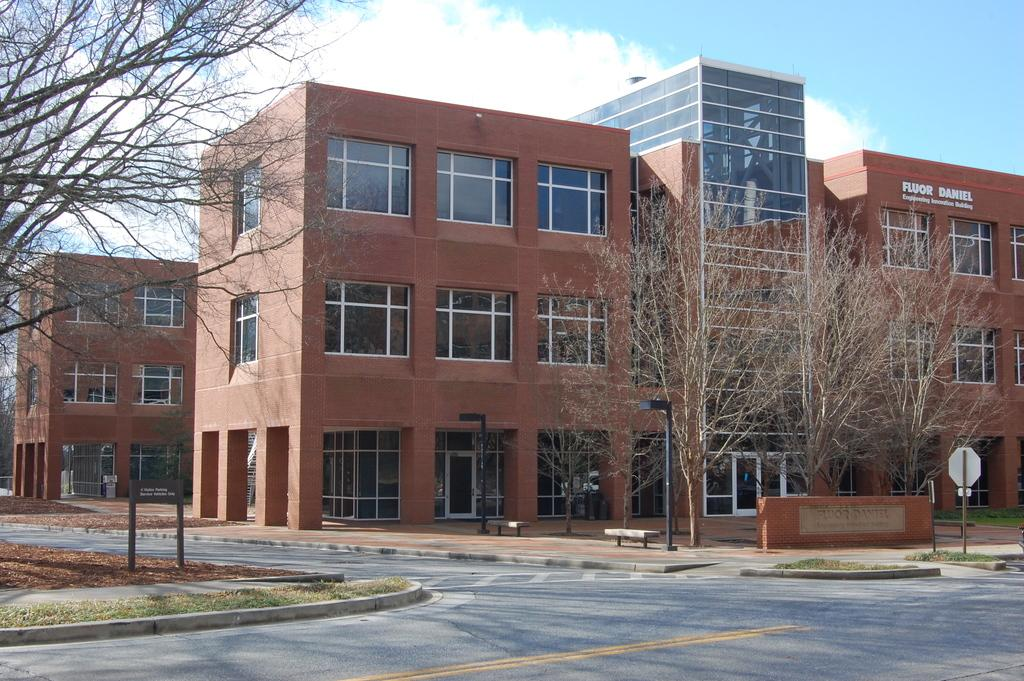What can be seen in the sky in the image? There are clouds in the sky in the image. What type of structures are present in the image? There are buildings in the image. What type of vegetation is present in the image? There are trees in the image. What type of seating is available in the image? There are benches in the image. What type of lighting is present in the image? There are streetlights in the image. What type of signage is present in the image? There is a board in the image. What type of ground cover is present in the image? There is grass in the image. What type of transportation infrastructure is present in the image? There is a road in the image. What type of advertisement is displayed on the board in the image? There is no advertisement displayed on the board in the image. What type of belief system is represented by the buildings in the image? The buildings in the image do not represent any specific belief system. What type of glue is used to attach the clouds to the sky in the image? The clouds in the image are not attached with glue; they are a natural part of the sky. 